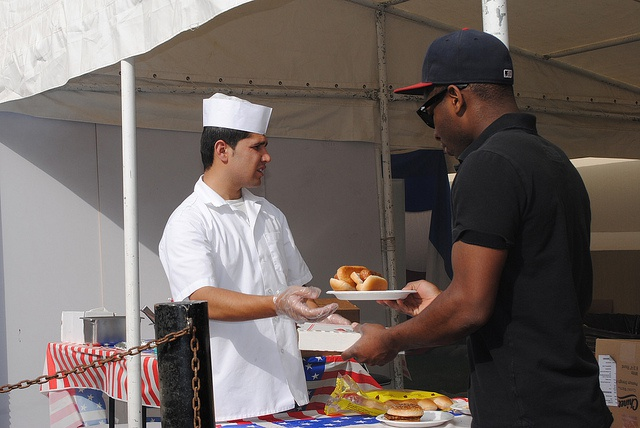Describe the objects in this image and their specific colors. I can see people in lightgray, black, maroon, and brown tones, people in lightgray, lavender, darkgray, gray, and tan tones, dining table in lightgray, darkgray, gray, and lightpink tones, dining table in lightgray, olive, and darkgray tones, and hot dog in lightgray, brown, and tan tones in this image. 